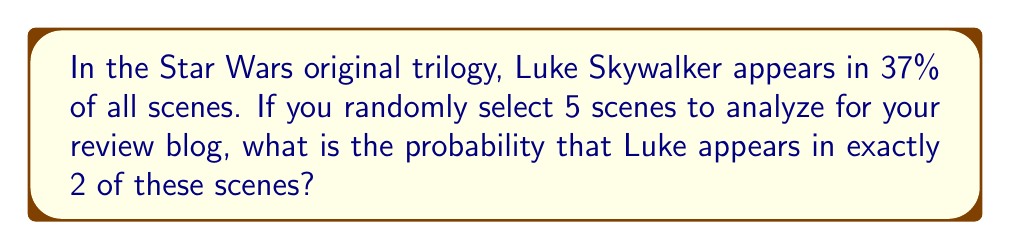Solve this math problem. Let's approach this step-by-step using the binomial probability distribution:

1) This scenario follows a binomial distribution because:
   - There are a fixed number of independent trials (5 scenes)
   - Each trial has two possible outcomes (Luke appears or doesn't appear)
   - The probability of success (Luke appearing) is constant for each trial

2) We can use the binomial probability formula:

   $$P(X=k) = \binom{n}{k} p^k (1-p)^{n-k}$$

   Where:
   $n$ = number of trials (5 scenes)
   $k$ = number of successes (2 appearances)
   $p$ = probability of success on each trial (0.37)

3) Let's plug in our values:

   $$P(X=2) = \binom{5}{2} (0.37)^2 (1-0.37)^{5-2}$$

4) Calculate the binomial coefficient:

   $$\binom{5}{2} = \frac{5!}{2!(5-2)!} = \frac{5 \cdot 4}{2 \cdot 1} = 10$$

5) Now our equation looks like:

   $$P(X=2) = 10 \cdot (0.37)^2 \cdot (0.63)^3$$

6) Calculate:

   $$P(X=2) = 10 \cdot 0.1369 \cdot 0.250047 = 0.342314$$

7) Round to four decimal places:

   $$P(X=2) \approx 0.3423$$
Answer: 0.3423 